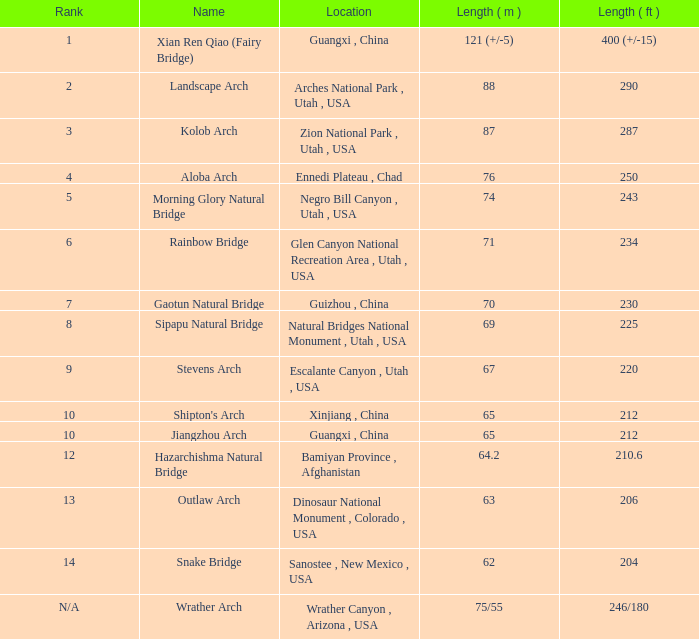Parse the table in full. {'header': ['Rank', 'Name', 'Location', 'Length ( m )', 'Length ( ft )'], 'rows': [['1', 'Xian Ren Qiao (Fairy Bridge)', 'Guangxi , China', '121 (+/-5)', '400 (+/-15)'], ['2', 'Landscape Arch', 'Arches National Park , Utah , USA', '88', '290'], ['3', 'Kolob Arch', 'Zion National Park , Utah , USA', '87', '287'], ['4', 'Aloba Arch', 'Ennedi Plateau , Chad', '76', '250'], ['5', 'Morning Glory Natural Bridge', 'Negro Bill Canyon , Utah , USA', '74', '243'], ['6', 'Rainbow Bridge', 'Glen Canyon National Recreation Area , Utah , USA', '71', '234'], ['7', 'Gaotun Natural Bridge', 'Guizhou , China', '70', '230'], ['8', 'Sipapu Natural Bridge', 'Natural Bridges National Monument , Utah , USA', '69', '225'], ['9', 'Stevens Arch', 'Escalante Canyon , Utah , USA', '67', '220'], ['10', "Shipton's Arch", 'Xinjiang , China', '65', '212'], ['10', 'Jiangzhou Arch', 'Guangxi , China', '65', '212'], ['12', 'Hazarchishma Natural Bridge', 'Bamiyan Province , Afghanistan', '64.2', '210.6'], ['13', 'Outlaw Arch', 'Dinosaur National Monument , Colorado , USA', '63', '206'], ['14', 'Snake Bridge', 'Sanostee , New Mexico , USA', '62', '204'], ['N/A', 'Wrather Arch', 'Wrather Canyon , Arizona , USA', '75/55', '246/180']]} What is the length in feet of the Jiangzhou arch? 212.0. 